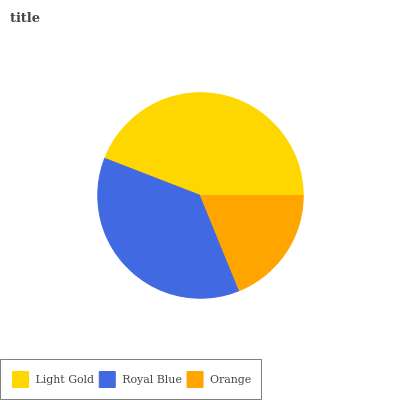Is Orange the minimum?
Answer yes or no. Yes. Is Light Gold the maximum?
Answer yes or no. Yes. Is Royal Blue the minimum?
Answer yes or no. No. Is Royal Blue the maximum?
Answer yes or no. No. Is Light Gold greater than Royal Blue?
Answer yes or no. Yes. Is Royal Blue less than Light Gold?
Answer yes or no. Yes. Is Royal Blue greater than Light Gold?
Answer yes or no. No. Is Light Gold less than Royal Blue?
Answer yes or no. No. Is Royal Blue the high median?
Answer yes or no. Yes. Is Royal Blue the low median?
Answer yes or no. Yes. Is Light Gold the high median?
Answer yes or no. No. Is Orange the low median?
Answer yes or no. No. 